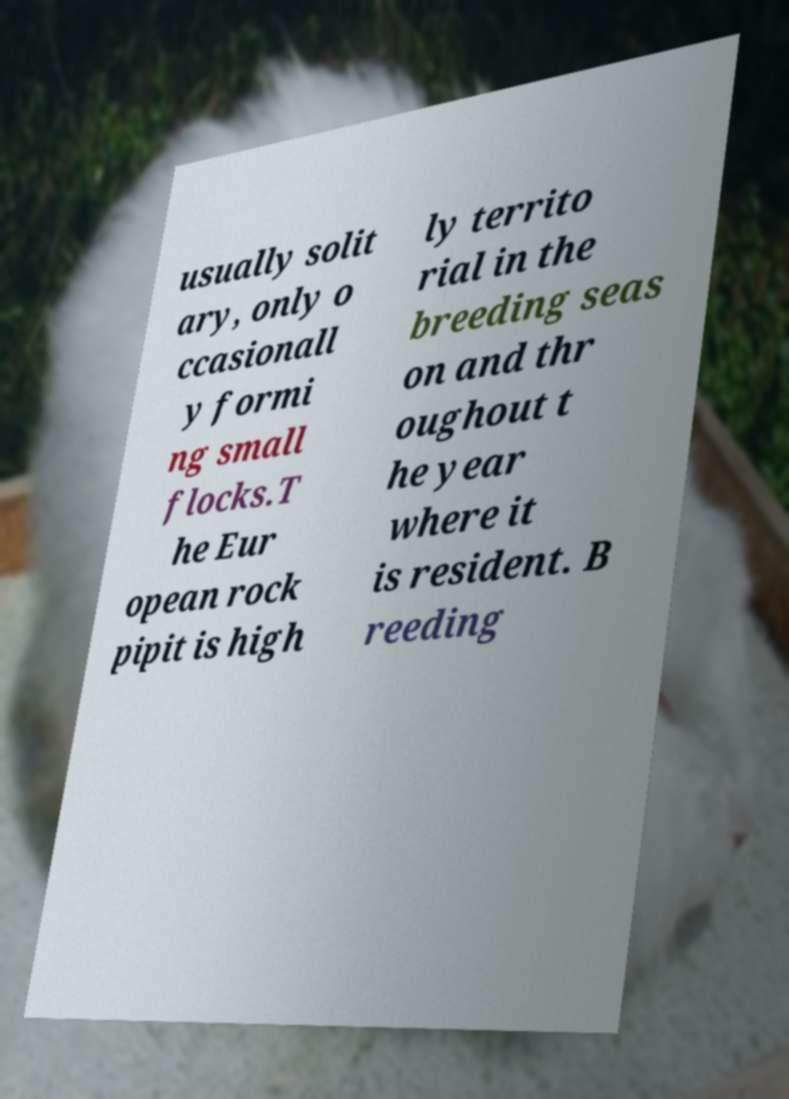Could you assist in decoding the text presented in this image and type it out clearly? usually solit ary, only o ccasionall y formi ng small flocks.T he Eur opean rock pipit is high ly territo rial in the breeding seas on and thr oughout t he year where it is resident. B reeding 